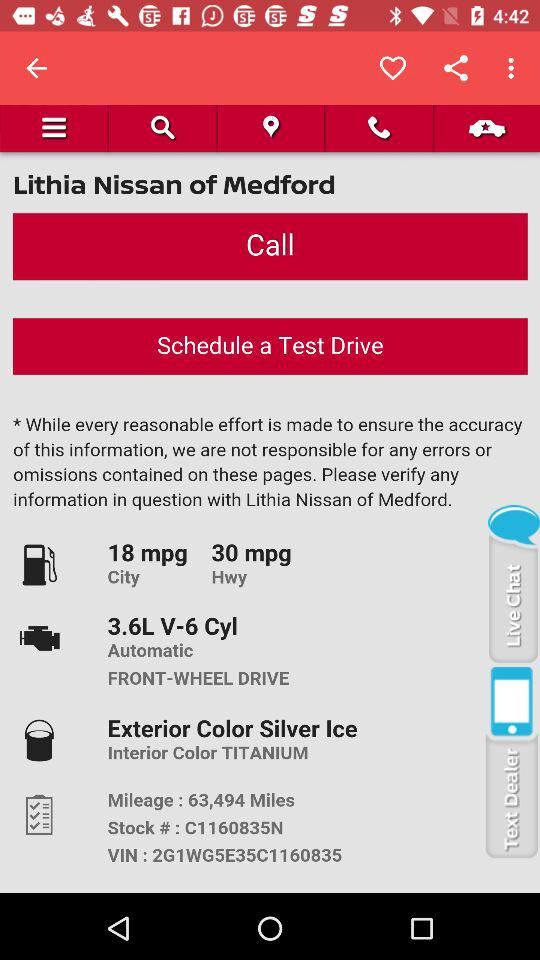How much mpg does it give on the highway? It gives 30 mpg on the highway. 